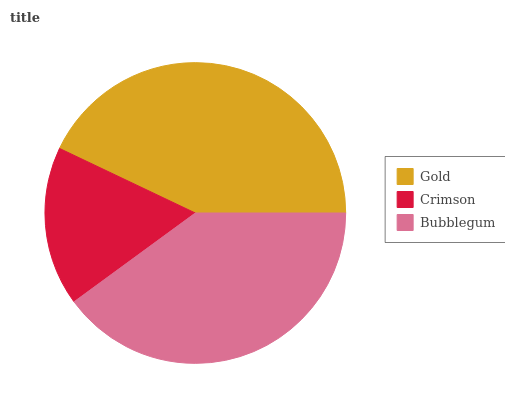Is Crimson the minimum?
Answer yes or no. Yes. Is Gold the maximum?
Answer yes or no. Yes. Is Bubblegum the minimum?
Answer yes or no. No. Is Bubblegum the maximum?
Answer yes or no. No. Is Bubblegum greater than Crimson?
Answer yes or no. Yes. Is Crimson less than Bubblegum?
Answer yes or no. Yes. Is Crimson greater than Bubblegum?
Answer yes or no. No. Is Bubblegum less than Crimson?
Answer yes or no. No. Is Bubblegum the high median?
Answer yes or no. Yes. Is Bubblegum the low median?
Answer yes or no. Yes. Is Gold the high median?
Answer yes or no. No. Is Crimson the low median?
Answer yes or no. No. 